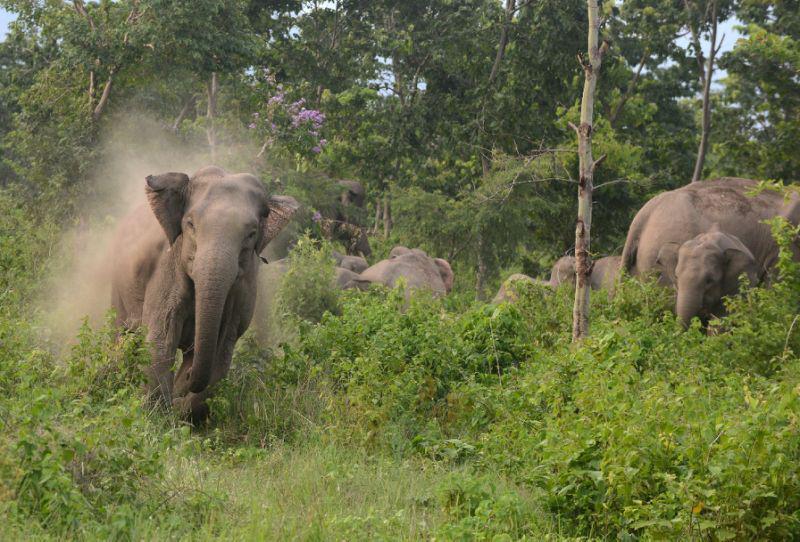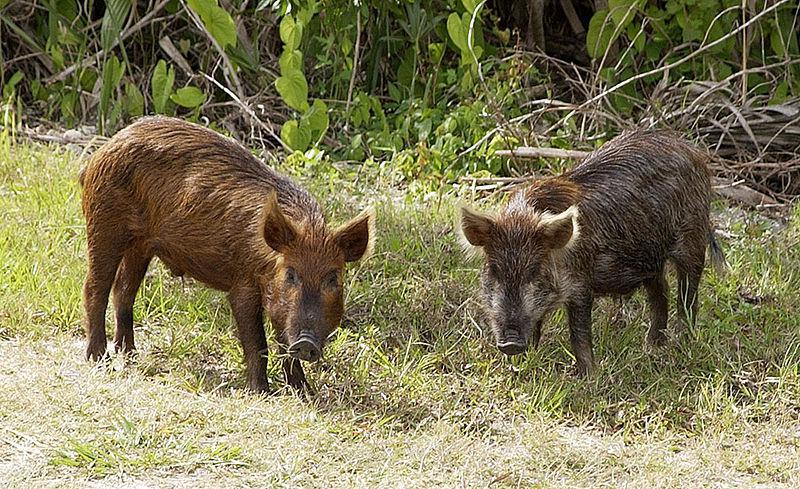The first image is the image on the left, the second image is the image on the right. Analyze the images presented: Is the assertion "There are two animals in the grassy area in the image on the right." valid? Answer yes or no. Yes. 